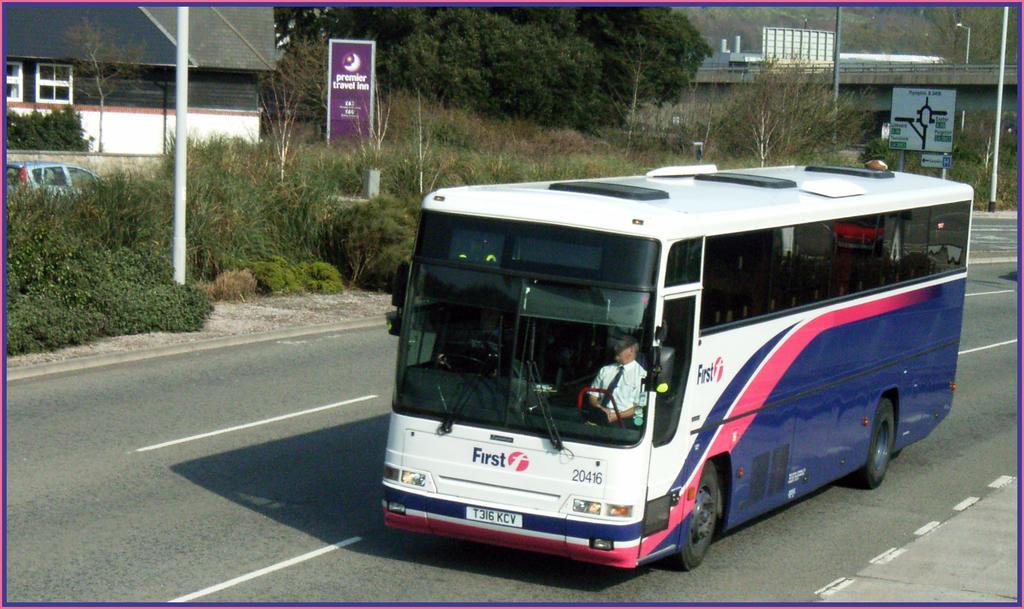Could you give a brief overview of what you see in this image? This image consists of trees and bushes at the top and middle. There are buildings at the top. There is a bus in the middle. There is a person sitting in that bus. 